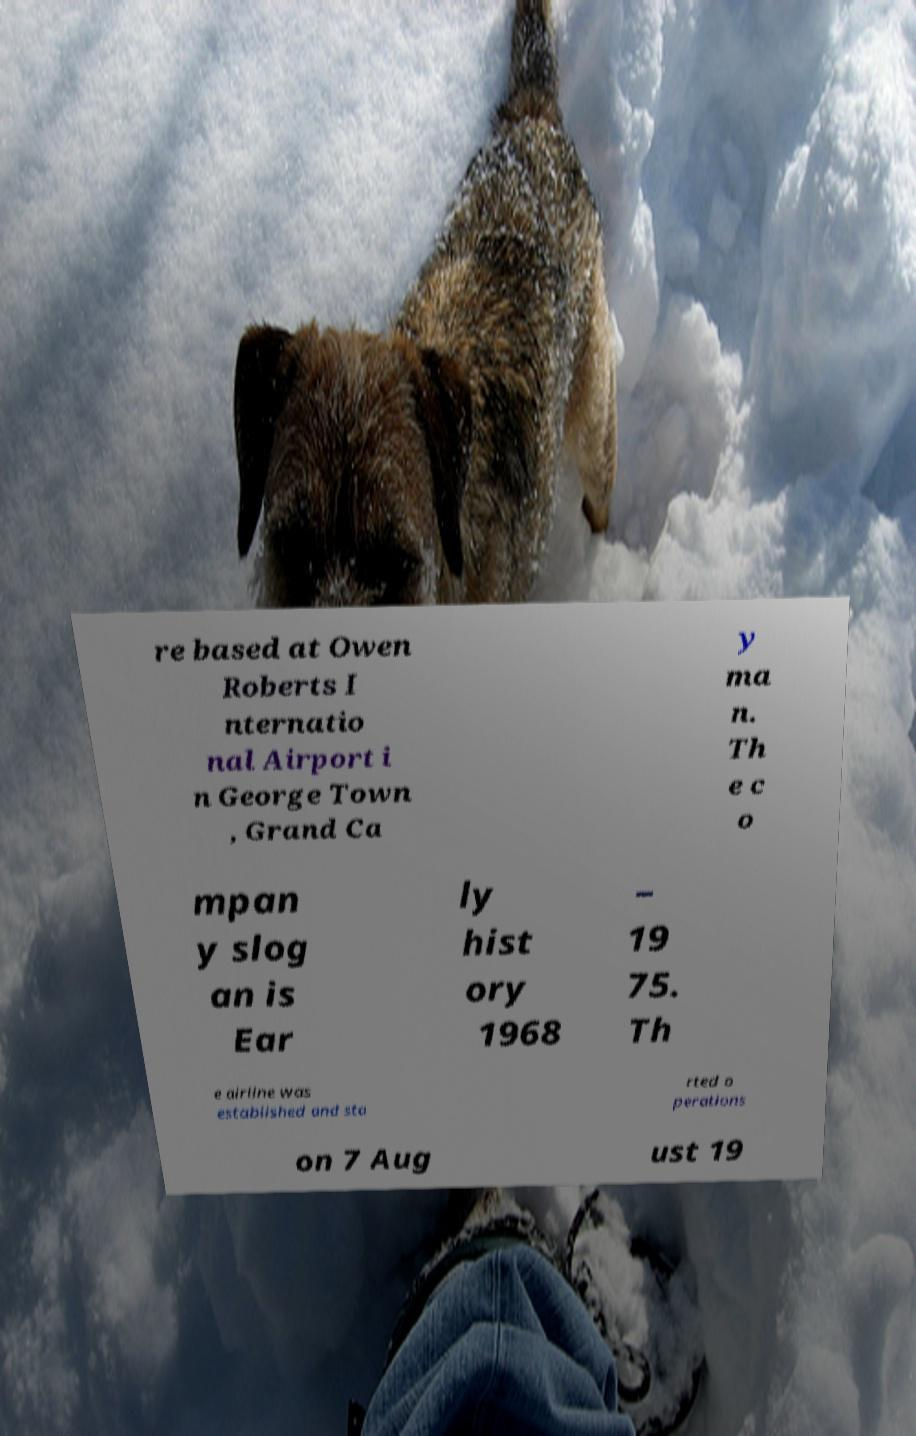Could you assist in decoding the text presented in this image and type it out clearly? re based at Owen Roberts I nternatio nal Airport i n George Town , Grand Ca y ma n. Th e c o mpan y slog an is Ear ly hist ory 1968 – 19 75. Th e airline was established and sta rted o perations on 7 Aug ust 19 